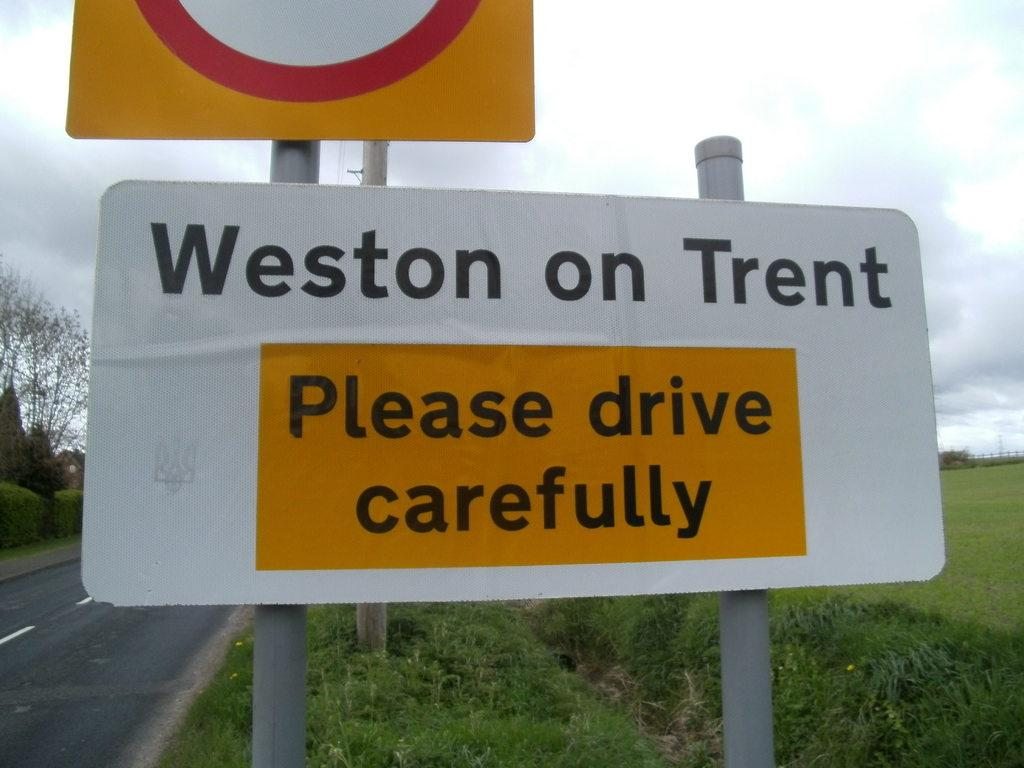<image>
Describe the image concisely. a sign that says please drive carefully on it 